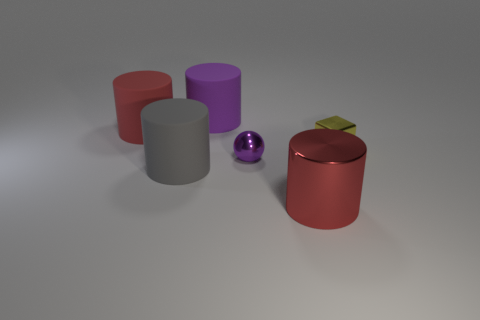The red matte thing is what shape?
Your response must be concise. Cylinder. How many purple metal things are the same shape as the red shiny object?
Offer a very short reply. 0. Is the number of gray things behind the purple matte cylinder less than the number of large purple matte objects that are to the left of the gray cylinder?
Offer a terse response. No. How many big metal cylinders are to the left of the red cylinder left of the purple rubber cylinder?
Ensure brevity in your answer.  0. Is there a big yellow cylinder?
Your answer should be compact. No. Is there a small ball that has the same material as the small yellow block?
Provide a succinct answer. Yes. Are there more purple shiny objects that are behind the red metal cylinder than tiny cubes right of the tiny yellow metal block?
Ensure brevity in your answer.  Yes. Does the red metal object have the same size as the block?
Keep it short and to the point. No. There is a large rubber cylinder in front of the matte cylinder that is left of the gray rubber thing; what color is it?
Give a very brief answer. Gray. What color is the block?
Give a very brief answer. Yellow. 